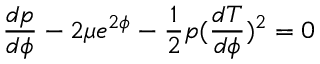Convert formula to latex. <formula><loc_0><loc_0><loc_500><loc_500>\frac { d p } { d \phi } - 2 \mu e ^ { 2 \phi } - \frac { 1 } { 2 } p ( \frac { d T } { d \phi } ) ^ { 2 } = 0</formula> 